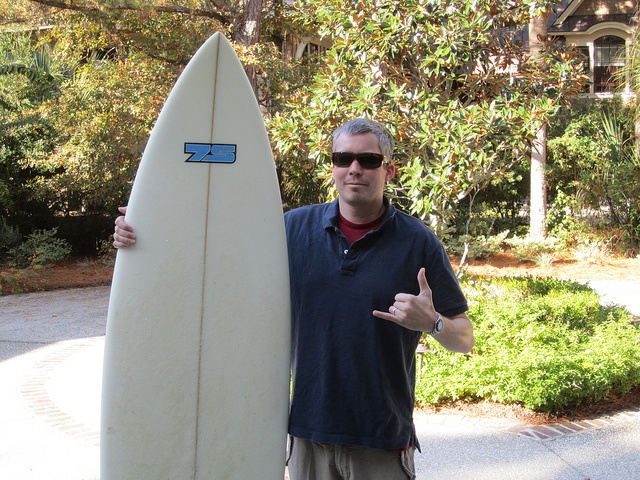Describe the objects in this image and their specific colors. I can see surfboard in tan, darkgray, lightgray, and gray tones and people in tan, black, gray, navy, and darkgray tones in this image. 